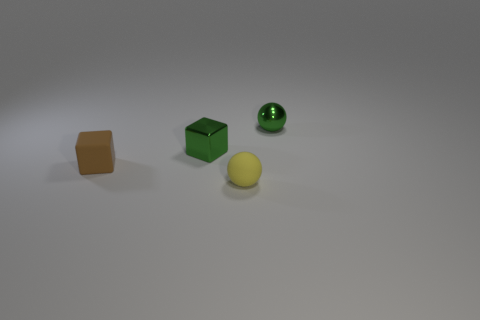What shape is the tiny metal thing that is the same color as the metal sphere?
Offer a very short reply. Cube. How many shiny things are brown cubes or small yellow things?
Offer a terse response. 0. What is the size of the other thing that is the same shape as the brown thing?
Your answer should be compact. Small. Are there any other things that have the same size as the brown cube?
Give a very brief answer. Yes. There is a yellow rubber ball; is its size the same as the cube that is on the right side of the tiny brown rubber cube?
Give a very brief answer. Yes. There is a shiny object that is to the right of the yellow rubber thing; what is its shape?
Offer a very short reply. Sphere. The small metal thing to the left of the small green object right of the small yellow ball is what color?
Provide a succinct answer. Green. The other shiny object that is the same shape as the yellow object is what color?
Provide a succinct answer. Green. How many shiny objects have the same color as the tiny metal ball?
Give a very brief answer. 1. Does the tiny metallic block have the same color as the matte object that is on the right side of the small shiny block?
Your answer should be very brief. No. 